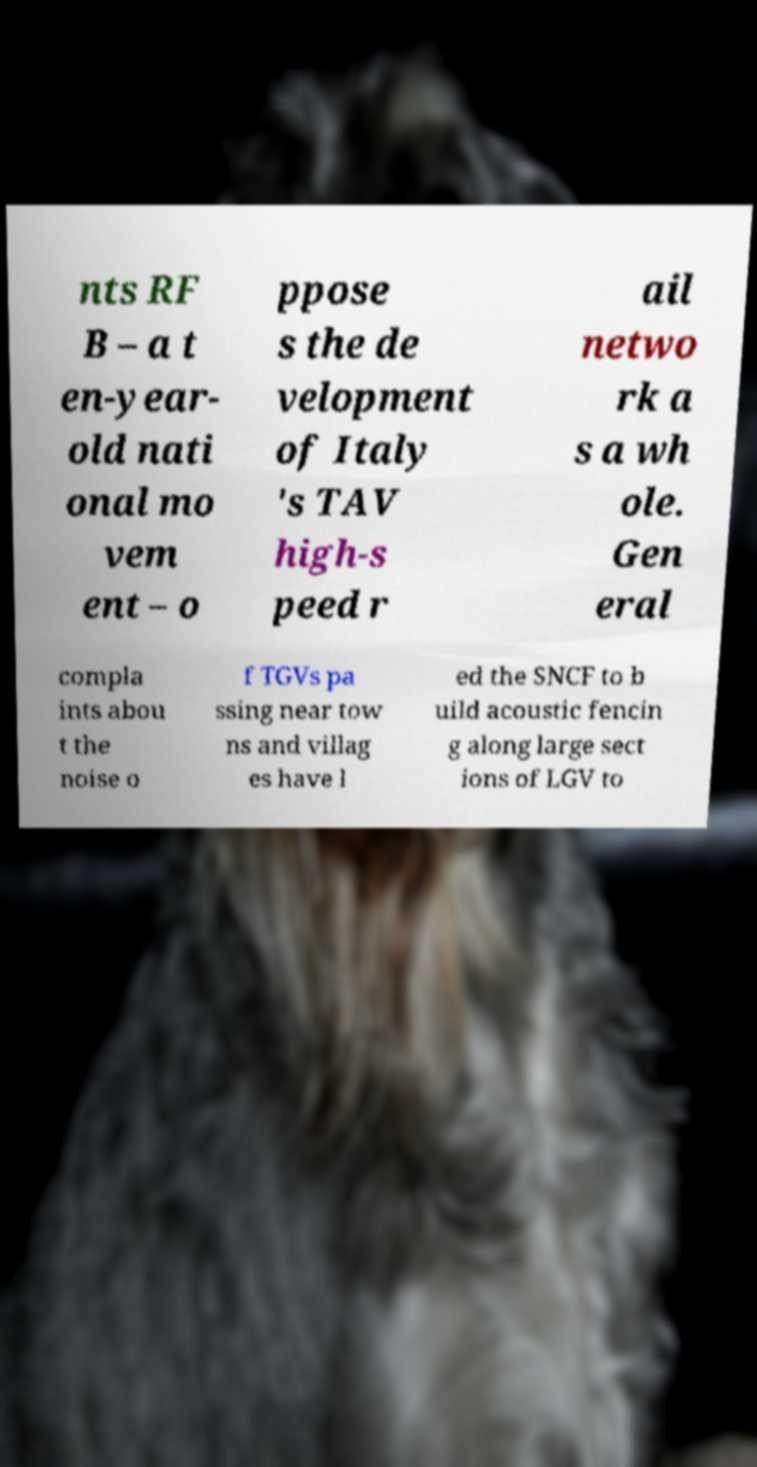Can you accurately transcribe the text from the provided image for me? nts RF B – a t en-year- old nati onal mo vem ent – o ppose s the de velopment of Italy 's TAV high-s peed r ail netwo rk a s a wh ole. Gen eral compla ints abou t the noise o f TGVs pa ssing near tow ns and villag es have l ed the SNCF to b uild acoustic fencin g along large sect ions of LGV to 